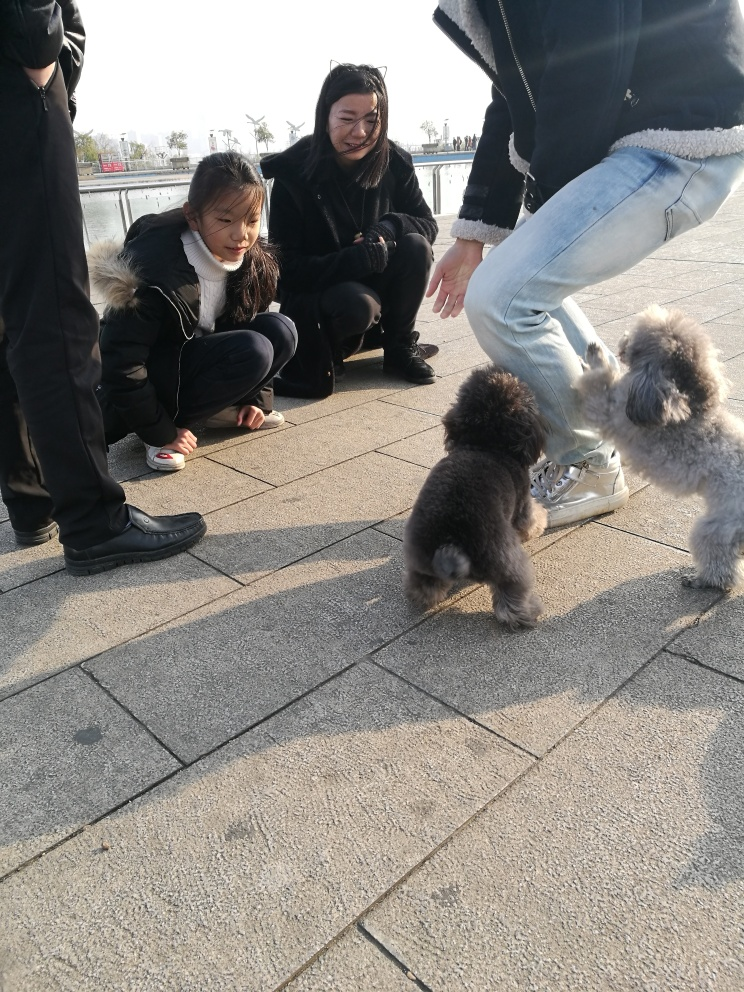What is the mood conveyed by the people interacting with the dogs? The mood in the image seems to be one of cheerful curiosity and gentle amusement. The individuals are crouching down to be at eye level with the dogs, displaying open body language that suggests friendliness and engagement. The slight smiles on their faces and their focused attention on the dogs convey a sense of enjoyment and delight in the interaction. 